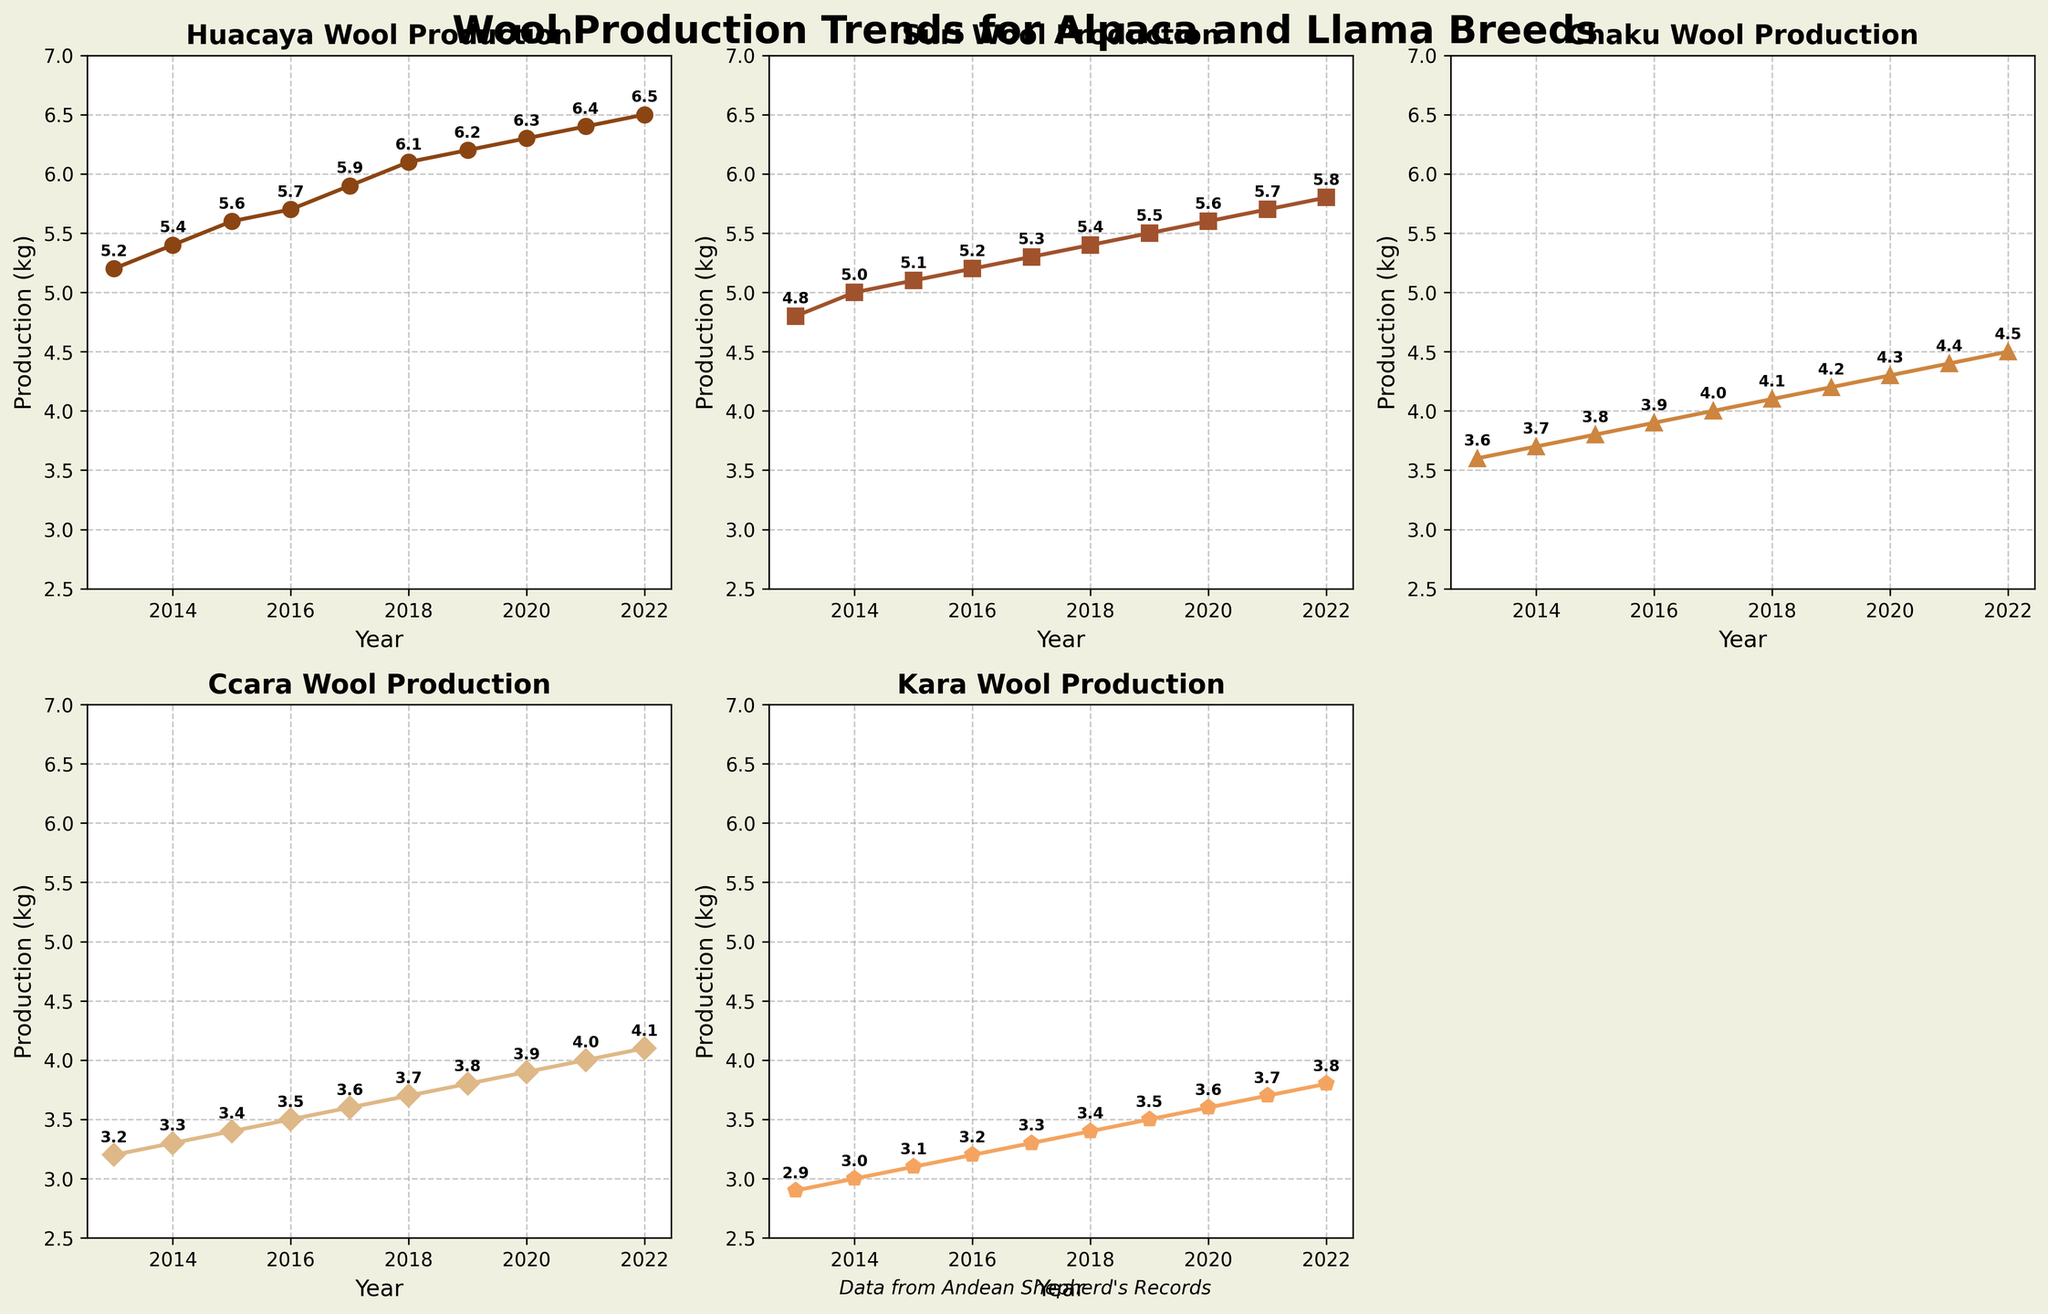What is the title of the overall figure? The title of the overall figure is the text displayed at the top center of the entire plot. It provides the subject or main idea of the plots. In this case, the title is 'Wool Production Trends for Alpaca and Llama Breeds', which indicates the main topic of the plots.
Answer: Wool Production Trends for Alpaca and Llama Breeds Which breed has the highest wool production in 2022? To determine which breed has the highest wool production in 2022, look at the last data point for each subplot. According to the plots, Huacaya has the highest wool production in that year.
Answer: Huacaya How has the wool production of the Suri breed changed from 2013 to 2022? To see how the wool production has changed over the years for Suri, look specifically at the Suri subplot and note the data points from 2013 to 2022. The production increases from 4.8 kg in 2013 to 5.8 kg in 2022.
Answer: Increased Which year marks the sharpest increase in wool production for the Chaku breed? Identify the year-to-year changes in wool production for the Chaku breed by examining the slope of the lines between data points on the Chaku subplot. The increase between 2016 and 2017, from 3.9 kg to 4.0 kg, appears to be one of the sharper inclines.
Answer: 2016-2017 What is the average wool production for the Kara breed over the decade? To calculate the average, sum the production values for each year from 2013 to 2022 and divide by the number of years. (2.9+3.0+3.1+3.2+3.3+3.4+3.5+3.6+3.7+3.8) / 10 = 3.35 kg
Answer: 3.35 kg How does the trend of wool production for Ccara compare to that of Huacaya? Compare the lines in the subplots for Ccara and Huacaya. Ccara shows a more moderate increasing trend compared to the steeper incline for Huacaya, indicating a faster production increase for Huacaya.
Answer: Huacaya increases more rapidly In which year did Huacaya's wool production surpass 6 kg? Look at the Huacaya subplot and find the point where the production first exceeds 6 kg. The line crosses the 6 kg mark between 2017 and 2018.
Answer: 2018 Which breed shows the most consistent increase in wool production over the years? Observe the slopes of the lines in each subplot. The breed with the most consistent slope, without large fluctuations year to year, is Huacaya.
Answer: Huacaya What is the difference in wool production between Ccara and Chaku in 2022? Subtract the wool production value of Ccara from that of Chaku in 2022. Ccara has 4.1 kg and Chaku has 4.5 kg, so 4.5 - 4.1 = 0.4 kg.
Answer: 0.4 kg 